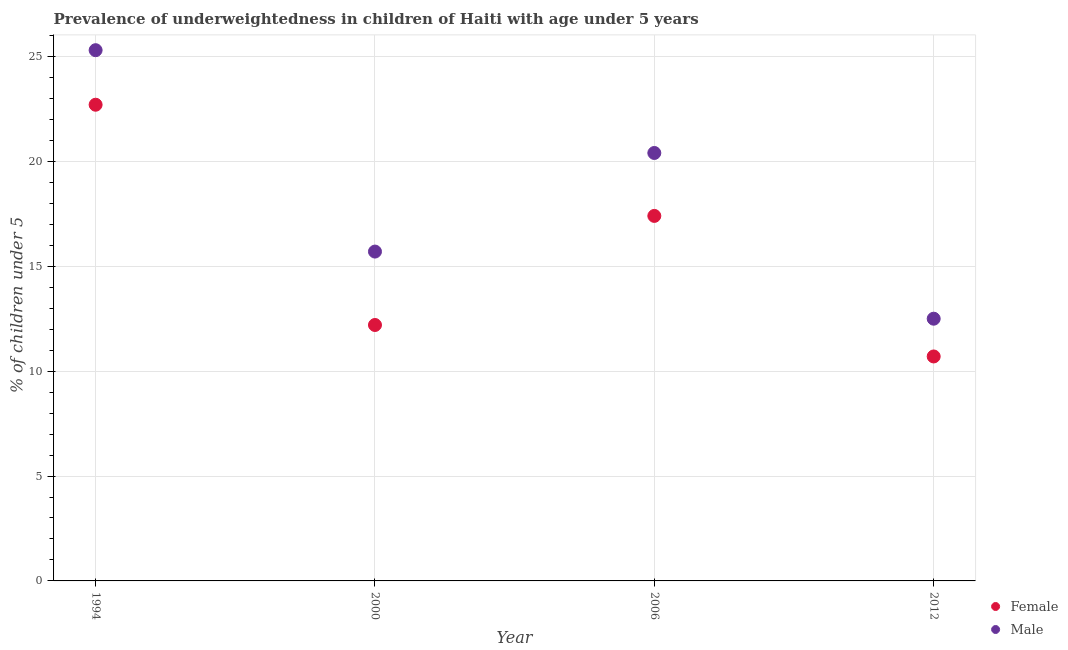How many different coloured dotlines are there?
Your response must be concise. 2. What is the percentage of underweighted male children in 2012?
Give a very brief answer. 12.5. Across all years, what is the maximum percentage of underweighted male children?
Your answer should be very brief. 25.3. Across all years, what is the minimum percentage of underweighted male children?
Offer a terse response. 12.5. What is the total percentage of underweighted female children in the graph?
Give a very brief answer. 63. What is the difference between the percentage of underweighted female children in 1994 and that in 2000?
Your answer should be very brief. 10.5. What is the difference between the percentage of underweighted male children in 2006 and the percentage of underweighted female children in 2000?
Your answer should be compact. 8.2. What is the average percentage of underweighted female children per year?
Keep it short and to the point. 15.75. In the year 2012, what is the difference between the percentage of underweighted female children and percentage of underweighted male children?
Your response must be concise. -1.8. What is the ratio of the percentage of underweighted female children in 1994 to that in 2006?
Make the answer very short. 1.3. What is the difference between the highest and the second highest percentage of underweighted female children?
Keep it short and to the point. 5.3. What is the difference between the highest and the lowest percentage of underweighted male children?
Your answer should be very brief. 12.8. In how many years, is the percentage of underweighted male children greater than the average percentage of underweighted male children taken over all years?
Your answer should be very brief. 2. Does the percentage of underweighted female children monotonically increase over the years?
Offer a terse response. No. Is the percentage of underweighted male children strictly greater than the percentage of underweighted female children over the years?
Your answer should be very brief. Yes. How many dotlines are there?
Offer a very short reply. 2. How many years are there in the graph?
Ensure brevity in your answer.  4. Are the values on the major ticks of Y-axis written in scientific E-notation?
Keep it short and to the point. No. Does the graph contain any zero values?
Keep it short and to the point. No. How many legend labels are there?
Give a very brief answer. 2. What is the title of the graph?
Keep it short and to the point. Prevalence of underweightedness in children of Haiti with age under 5 years. Does "Manufacturing industries and construction" appear as one of the legend labels in the graph?
Your answer should be compact. No. What is the label or title of the Y-axis?
Your answer should be very brief.  % of children under 5. What is the  % of children under 5 in Female in 1994?
Give a very brief answer. 22.7. What is the  % of children under 5 of Male in 1994?
Your answer should be very brief. 25.3. What is the  % of children under 5 in Female in 2000?
Ensure brevity in your answer.  12.2. What is the  % of children under 5 of Male in 2000?
Make the answer very short. 15.7. What is the  % of children under 5 of Female in 2006?
Keep it short and to the point. 17.4. What is the  % of children under 5 of Male in 2006?
Keep it short and to the point. 20.4. What is the  % of children under 5 in Female in 2012?
Your answer should be very brief. 10.7. What is the  % of children under 5 of Male in 2012?
Make the answer very short. 12.5. Across all years, what is the maximum  % of children under 5 of Female?
Ensure brevity in your answer.  22.7. Across all years, what is the maximum  % of children under 5 in Male?
Keep it short and to the point. 25.3. Across all years, what is the minimum  % of children under 5 of Female?
Provide a succinct answer. 10.7. Across all years, what is the minimum  % of children under 5 in Male?
Your answer should be compact. 12.5. What is the total  % of children under 5 of Female in the graph?
Provide a short and direct response. 63. What is the total  % of children under 5 in Male in the graph?
Provide a short and direct response. 73.9. What is the difference between the  % of children under 5 in Female in 1994 and that in 2006?
Ensure brevity in your answer.  5.3. What is the difference between the  % of children under 5 of Male in 1994 and that in 2012?
Provide a short and direct response. 12.8. What is the difference between the  % of children under 5 of Male in 2000 and that in 2012?
Offer a terse response. 3.2. What is the difference between the  % of children under 5 in Female in 2006 and that in 2012?
Make the answer very short. 6.7. What is the difference between the  % of children under 5 of Female in 1994 and the  % of children under 5 of Male in 2012?
Your answer should be compact. 10.2. What is the difference between the  % of children under 5 in Female in 2000 and the  % of children under 5 in Male in 2006?
Offer a terse response. -8.2. What is the average  % of children under 5 in Female per year?
Make the answer very short. 15.75. What is the average  % of children under 5 of Male per year?
Your response must be concise. 18.48. What is the ratio of the  % of children under 5 in Female in 1994 to that in 2000?
Ensure brevity in your answer.  1.86. What is the ratio of the  % of children under 5 of Male in 1994 to that in 2000?
Offer a terse response. 1.61. What is the ratio of the  % of children under 5 in Female in 1994 to that in 2006?
Give a very brief answer. 1.3. What is the ratio of the  % of children under 5 in Male in 1994 to that in 2006?
Provide a succinct answer. 1.24. What is the ratio of the  % of children under 5 in Female in 1994 to that in 2012?
Provide a succinct answer. 2.12. What is the ratio of the  % of children under 5 of Male in 1994 to that in 2012?
Make the answer very short. 2.02. What is the ratio of the  % of children under 5 in Female in 2000 to that in 2006?
Give a very brief answer. 0.7. What is the ratio of the  % of children under 5 of Male in 2000 to that in 2006?
Make the answer very short. 0.77. What is the ratio of the  % of children under 5 in Female in 2000 to that in 2012?
Give a very brief answer. 1.14. What is the ratio of the  % of children under 5 of Male in 2000 to that in 2012?
Your answer should be compact. 1.26. What is the ratio of the  % of children under 5 in Female in 2006 to that in 2012?
Ensure brevity in your answer.  1.63. What is the ratio of the  % of children under 5 in Male in 2006 to that in 2012?
Make the answer very short. 1.63. What is the difference between the highest and the second highest  % of children under 5 in Male?
Your answer should be compact. 4.9. 